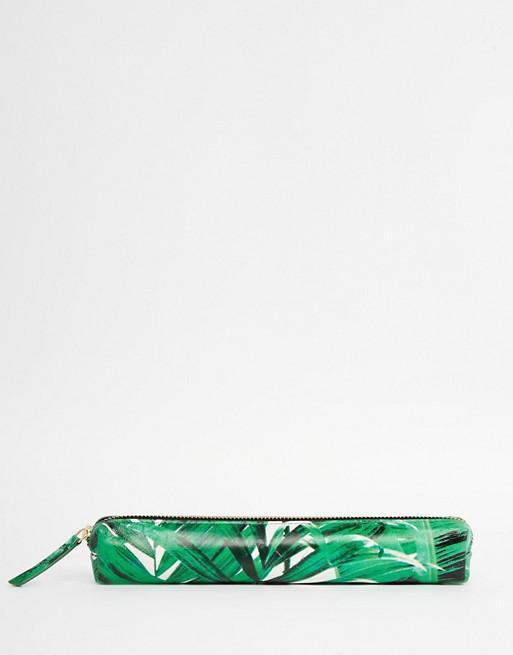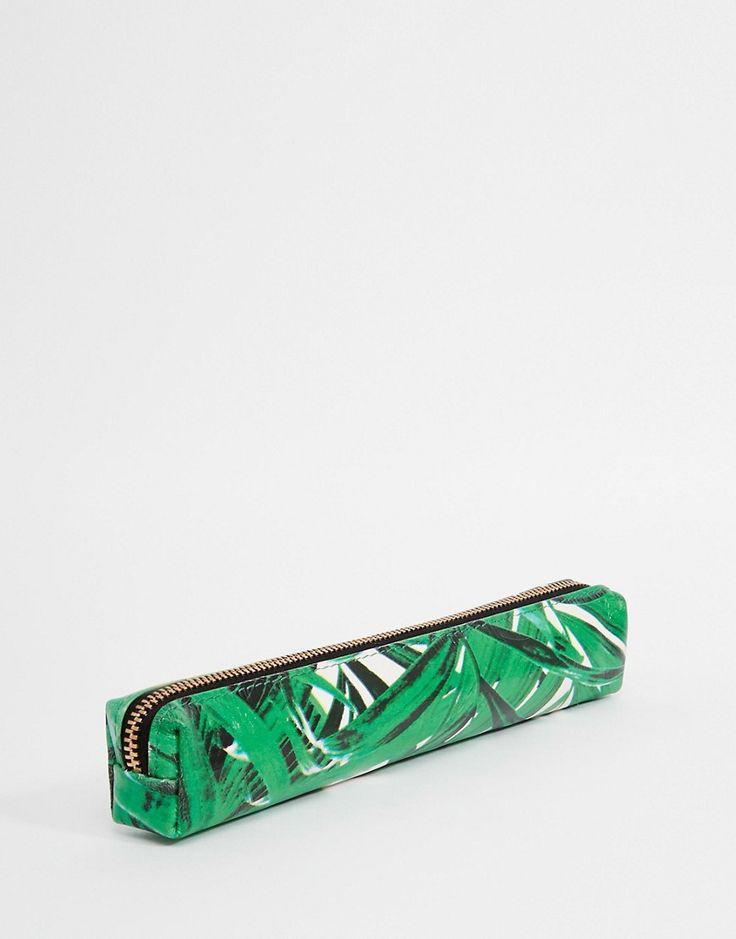The first image is the image on the left, the second image is the image on the right. Assess this claim about the two images: "One image shows just one pencil case, which has eyes.". Correct or not? Answer yes or no. No. The first image is the image on the left, the second image is the image on the right. Considering the images on both sides, is "One pencil case is unzipped and at least three are closed." valid? Answer yes or no. No. 